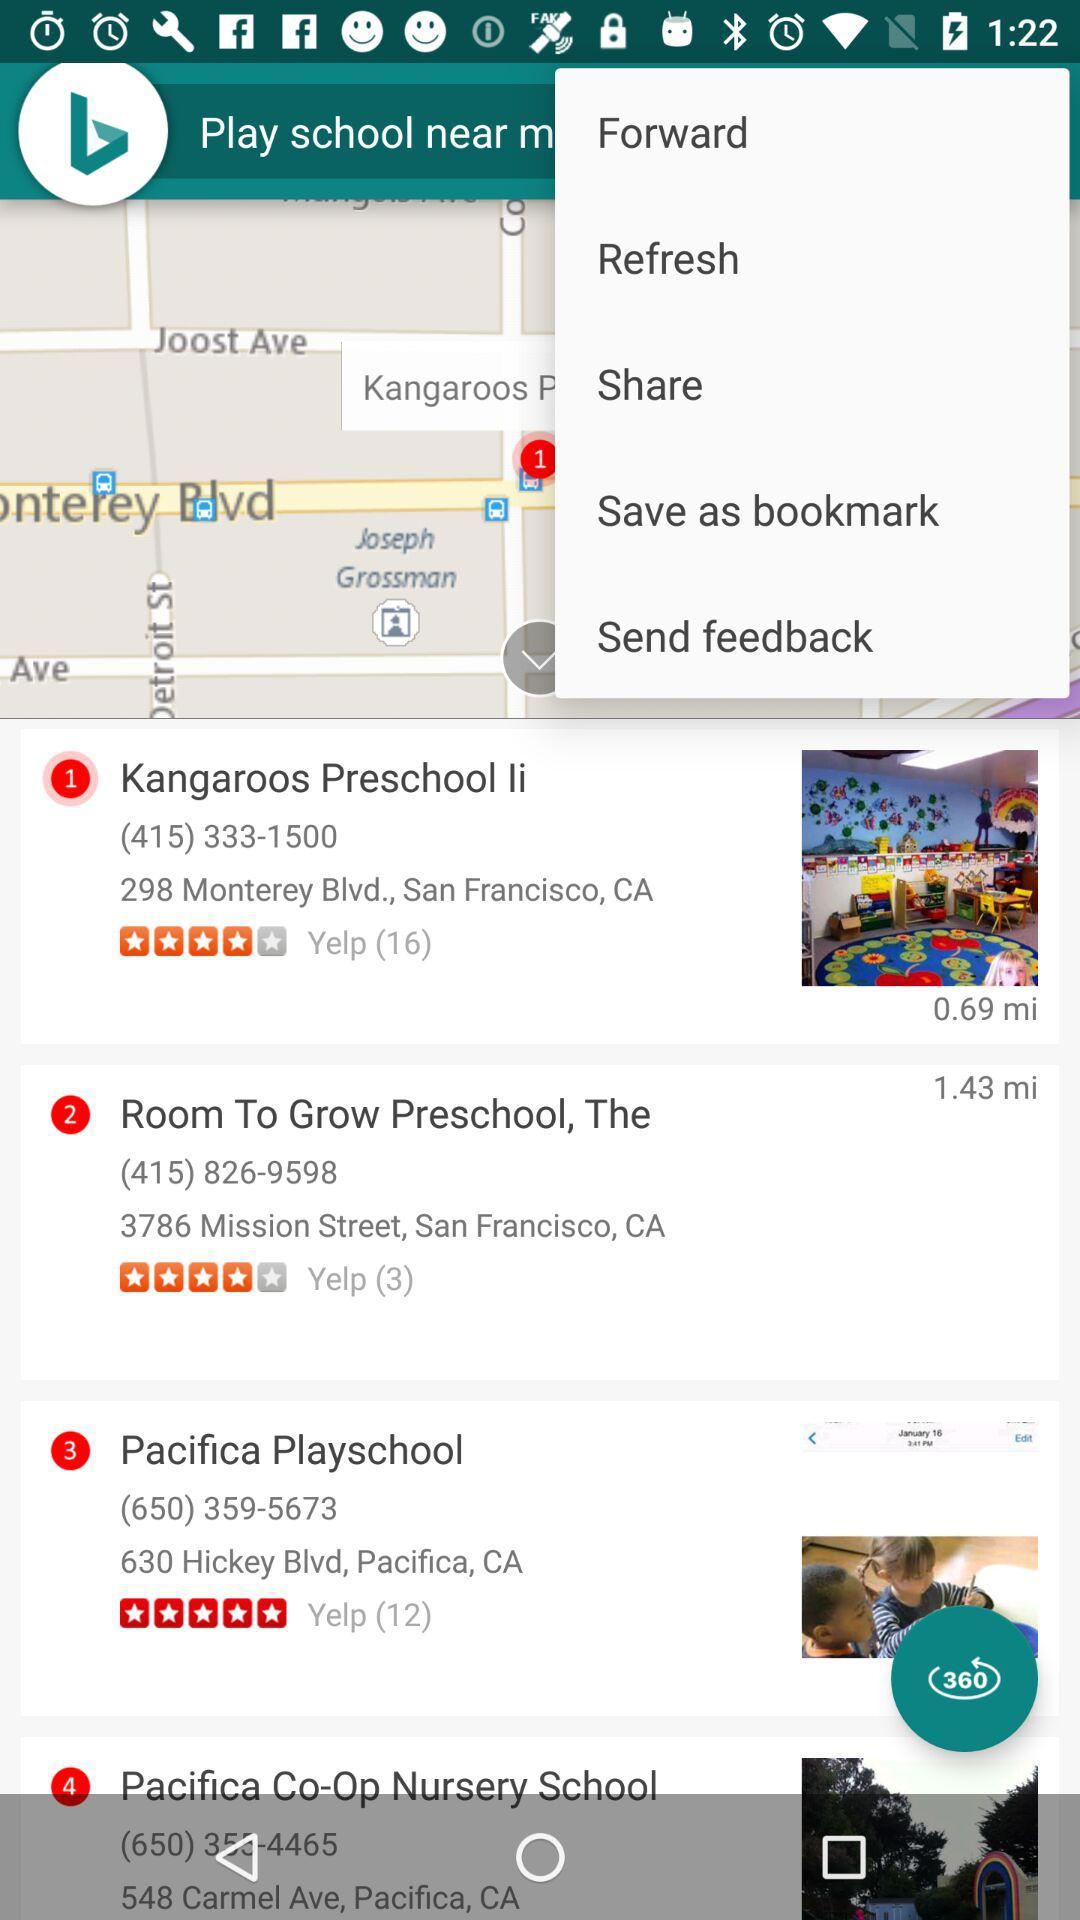What's the contact number for "Kangaroos Preschool li"? The contact number for "Kangaroos Preschool li" is (415) 333-1500. 